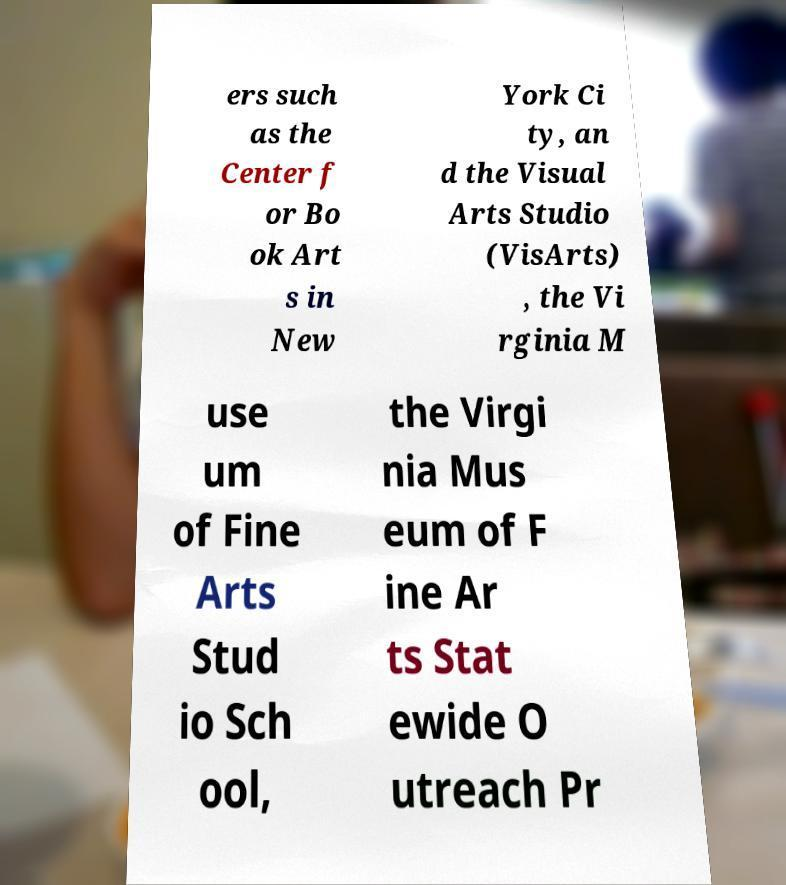Can you read and provide the text displayed in the image?This photo seems to have some interesting text. Can you extract and type it out for me? ers such as the Center f or Bo ok Art s in New York Ci ty, an d the Visual Arts Studio (VisArts) , the Vi rginia M use um of Fine Arts Stud io Sch ool, the Virgi nia Mus eum of F ine Ar ts Stat ewide O utreach Pr 